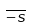Convert formula to latex. <formula><loc_0><loc_0><loc_500><loc_500>\overline { - s }</formula> 